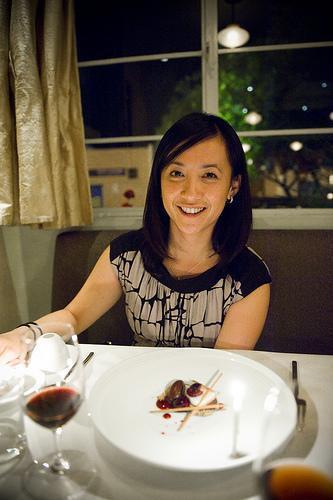How many plates are there?
Give a very brief answer. 1. 